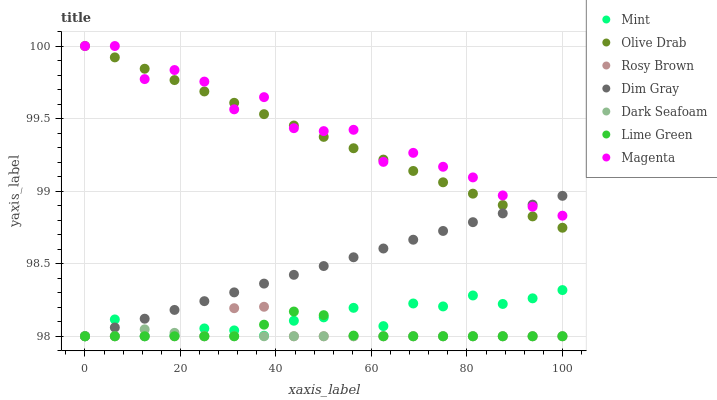Does Dark Seafoam have the minimum area under the curve?
Answer yes or no. Yes. Does Magenta have the maximum area under the curve?
Answer yes or no. Yes. Does Mint have the minimum area under the curve?
Answer yes or no. No. Does Mint have the maximum area under the curve?
Answer yes or no. No. Is Olive Drab the smoothest?
Answer yes or no. Yes. Is Magenta the roughest?
Answer yes or no. Yes. Is Mint the smoothest?
Answer yes or no. No. Is Mint the roughest?
Answer yes or no. No. Does Dim Gray have the lowest value?
Answer yes or no. Yes. Does Magenta have the lowest value?
Answer yes or no. No. Does Olive Drab have the highest value?
Answer yes or no. Yes. Does Mint have the highest value?
Answer yes or no. No. Is Lime Green less than Olive Drab?
Answer yes or no. Yes. Is Olive Drab greater than Dark Seafoam?
Answer yes or no. Yes. Does Dim Gray intersect Rosy Brown?
Answer yes or no. Yes. Is Dim Gray less than Rosy Brown?
Answer yes or no. No. Is Dim Gray greater than Rosy Brown?
Answer yes or no. No. Does Lime Green intersect Olive Drab?
Answer yes or no. No. 